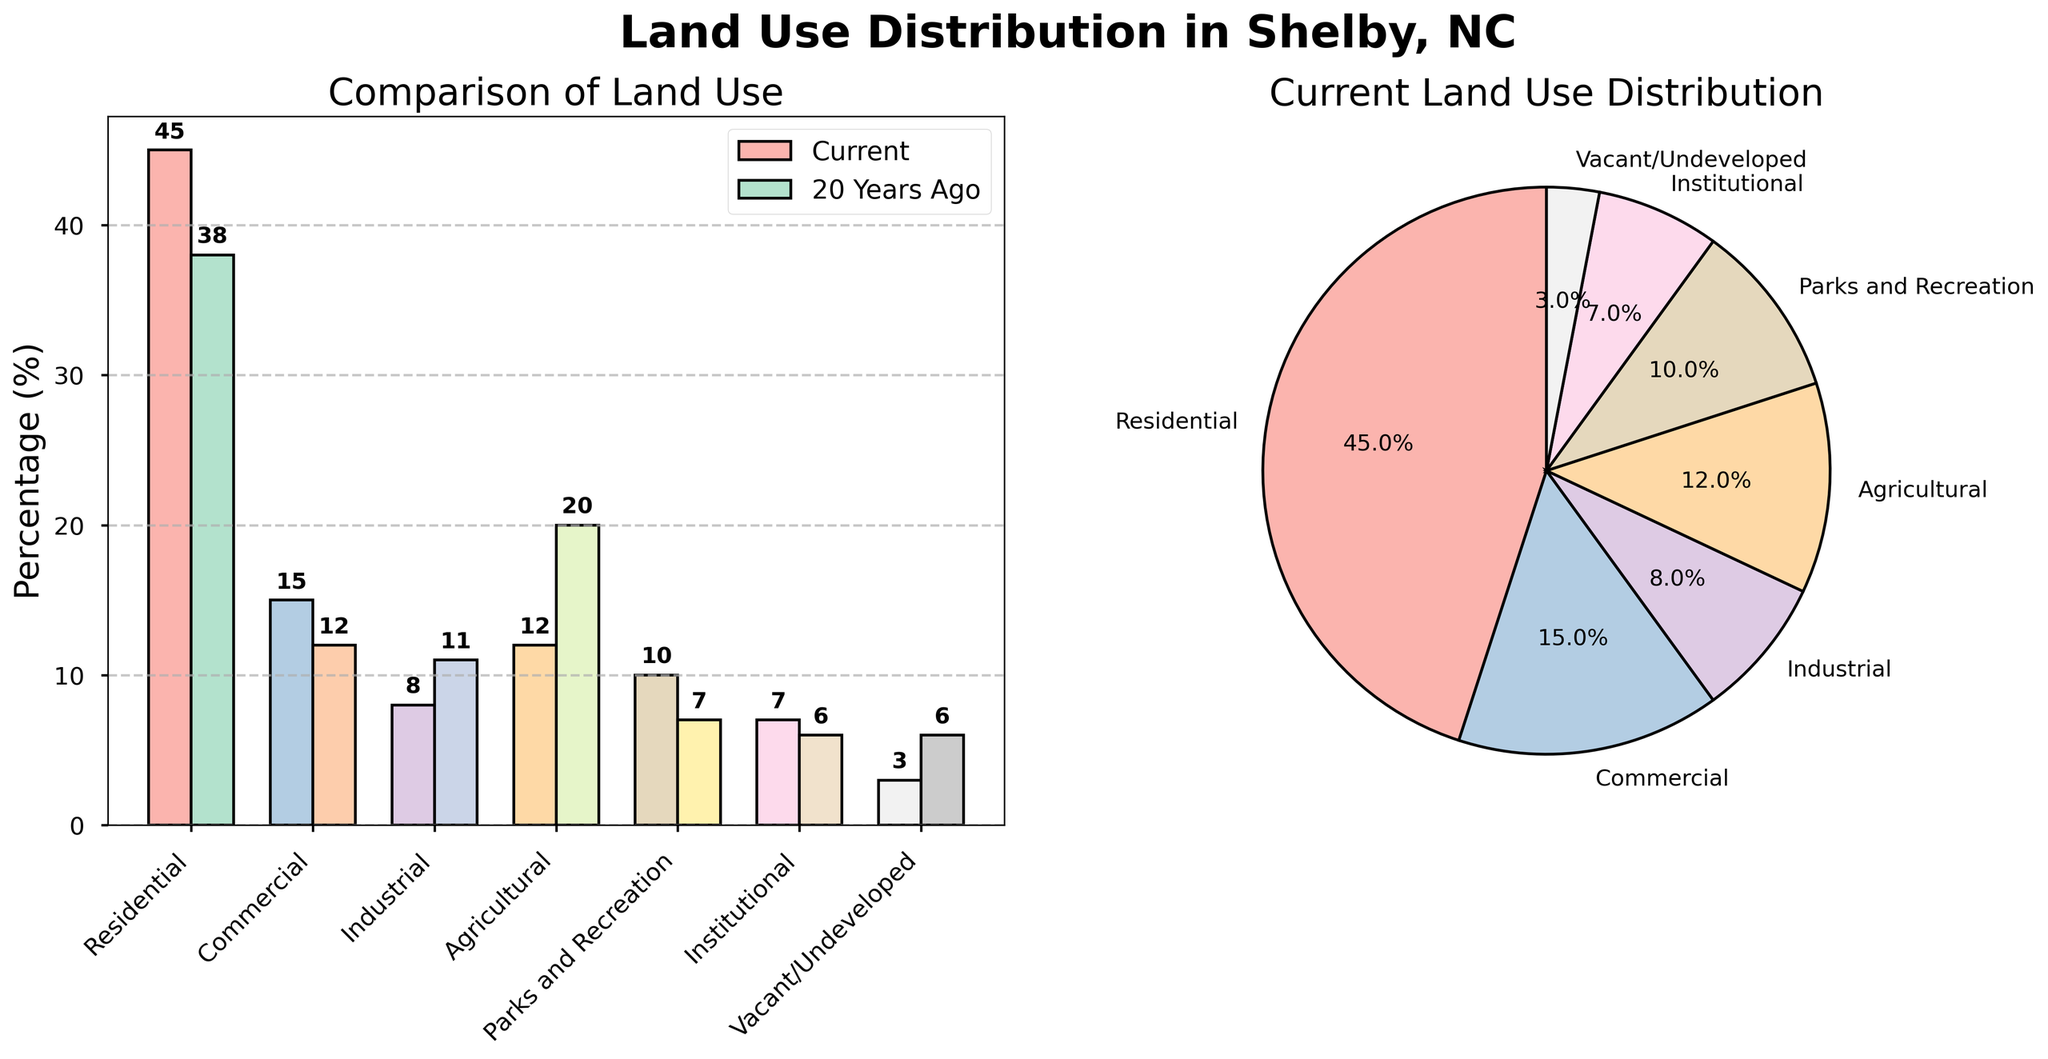What's the title of the chart comparing land use in Shelby, NC? The title is typically at the top of the chart, indicating the subject of the figure.
Answer: Land Use Distribution in Shelby, NC What is the percentage of residential land use currently and 20 years ago? Look at the bar chart and identify the bars representing residential land use; the current is in one color and 20 years ago is in another.
Answer: 45% currently, 38% 20 years ago Which land use type has decreased the most over the last 20 years? Compare the bars from 20 years ago to the current ones; the biggest drop will show the greatest decrease in percentage.
Answer: Agricultural How many land use types are displayed in the bar chart? Count the number of distinct categories shown along the x-axis.
Answer: 7 Which land use type experienced the highest percentage increase over the past 20 years? Compare the current and past percentages for each land use type; the highest positive difference indicates the greatest increase.
Answer: Residential What's the total percentage of current land use classified as Residential, Commercial, and Parks and Recreation? Sum the current percentages of these three categories: Residential (45), Commercial (15), and Parks and Recreation (10).
Answer: 70% What is the percentage difference in vacant/undeveloped land from 20 years ago to now? Subtract the current percentage of vacant/undeveloped land from the percentage 20 years ago (6 - 3).
Answer: 3% Which category has more land use currently: Institutional or Industrial? Compare the current percentages of Institutional (7%) and Industrial (8%) land uses.
Answer: Industrial What percentage does Commercial land use constitute in the current pie chart? Look at the current land use pie chart and identify the percentage label for Commercial land use.
Answer: 15% Which land use type remains less than 10% both currently and 20 years ago? Identify categories where both current and 20 years ago percentages are less than 10%.
Answer: Institutional 